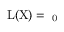<formula> <loc_0><loc_0><loc_500><loc_500>{ { L } ( X ) = \aleph _ { 0 } }</formula> 